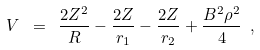Convert formula to latex. <formula><loc_0><loc_0><loc_500><loc_500>V \ = \ \frac { 2 Z ^ { 2 } } { R } - \frac { 2 Z } { r _ { 1 } } - \frac { 2 Z } { r _ { 2 } } + \frac { B ^ { 2 } \rho ^ { 2 } } { 4 } \ ,</formula> 